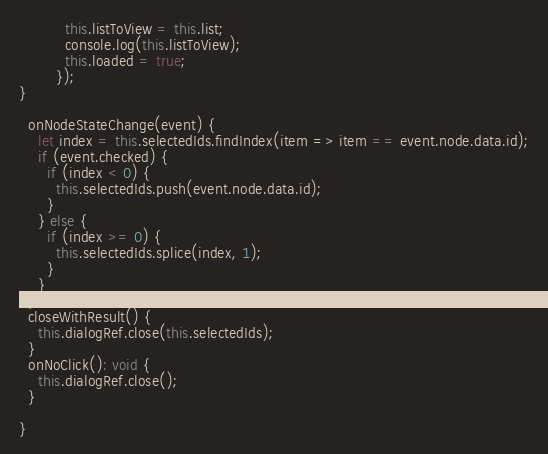<code> <loc_0><loc_0><loc_500><loc_500><_TypeScript_>          this.listToView = this.list;
          console.log(this.listToView);
          this.loaded = true;
        });
}

  onNodeStateChange(event) {
    let index = this.selectedIds.findIndex(item => item == event.node.data.id);
    if (event.checked) {
      if (index < 0) {
        this.selectedIds.push(event.node.data.id);
      }
    } else {
      if (index >= 0) {
        this.selectedIds.splice(index, 1);
      }
    }
  }
  closeWithResult() {
    this.dialogRef.close(this.selectedIds);
  }
  onNoClick(): void {
    this.dialogRef.close();
  }

}
</code> 